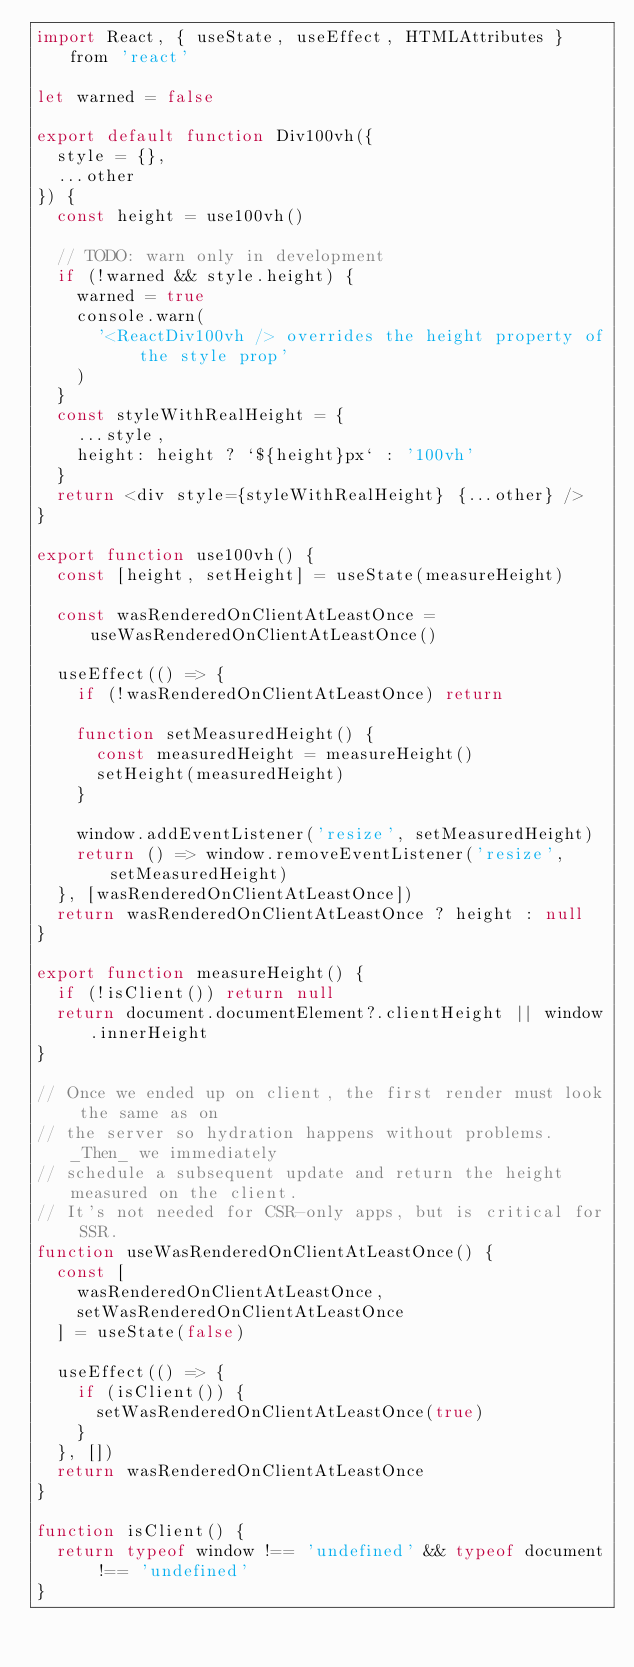Convert code to text. <code><loc_0><loc_0><loc_500><loc_500><_JavaScript_>import React, { useState, useEffect, HTMLAttributes } from 'react'

let warned = false

export default function Div100vh({
  style = {},
  ...other
}) {
  const height = use100vh()

  // TODO: warn only in development
  if (!warned && style.height) {
    warned = true
    console.warn(
      '<ReactDiv100vh /> overrides the height property of the style prop'
    )
  }
  const styleWithRealHeight = {
    ...style,
    height: height ? `${height}px` : '100vh'
  }
  return <div style={styleWithRealHeight} {...other} />
}

export function use100vh() {
  const [height, setHeight] = useState(measureHeight)

  const wasRenderedOnClientAtLeastOnce = useWasRenderedOnClientAtLeastOnce()

  useEffect(() => {
    if (!wasRenderedOnClientAtLeastOnce) return

    function setMeasuredHeight() {
      const measuredHeight = measureHeight()
      setHeight(measuredHeight)
    }

    window.addEventListener('resize', setMeasuredHeight)
    return () => window.removeEventListener('resize', setMeasuredHeight)
  }, [wasRenderedOnClientAtLeastOnce])
  return wasRenderedOnClientAtLeastOnce ? height : null
}

export function measureHeight() {
  if (!isClient()) return null
  return document.documentElement?.clientHeight || window.innerHeight
}

// Once we ended up on client, the first render must look the same as on
// the server so hydration happens without problems. _Then_ we immediately
// schedule a subsequent update and return the height measured on the client.
// It's not needed for CSR-only apps, but is critical for SSR.
function useWasRenderedOnClientAtLeastOnce() {
  const [
    wasRenderedOnClientAtLeastOnce,
    setWasRenderedOnClientAtLeastOnce
  ] = useState(false)

  useEffect(() => {
    if (isClient()) {
      setWasRenderedOnClientAtLeastOnce(true)
    }
  }, [])
  return wasRenderedOnClientAtLeastOnce
}

function isClient() {
  return typeof window !== 'undefined' && typeof document !== 'undefined'
}
</code> 